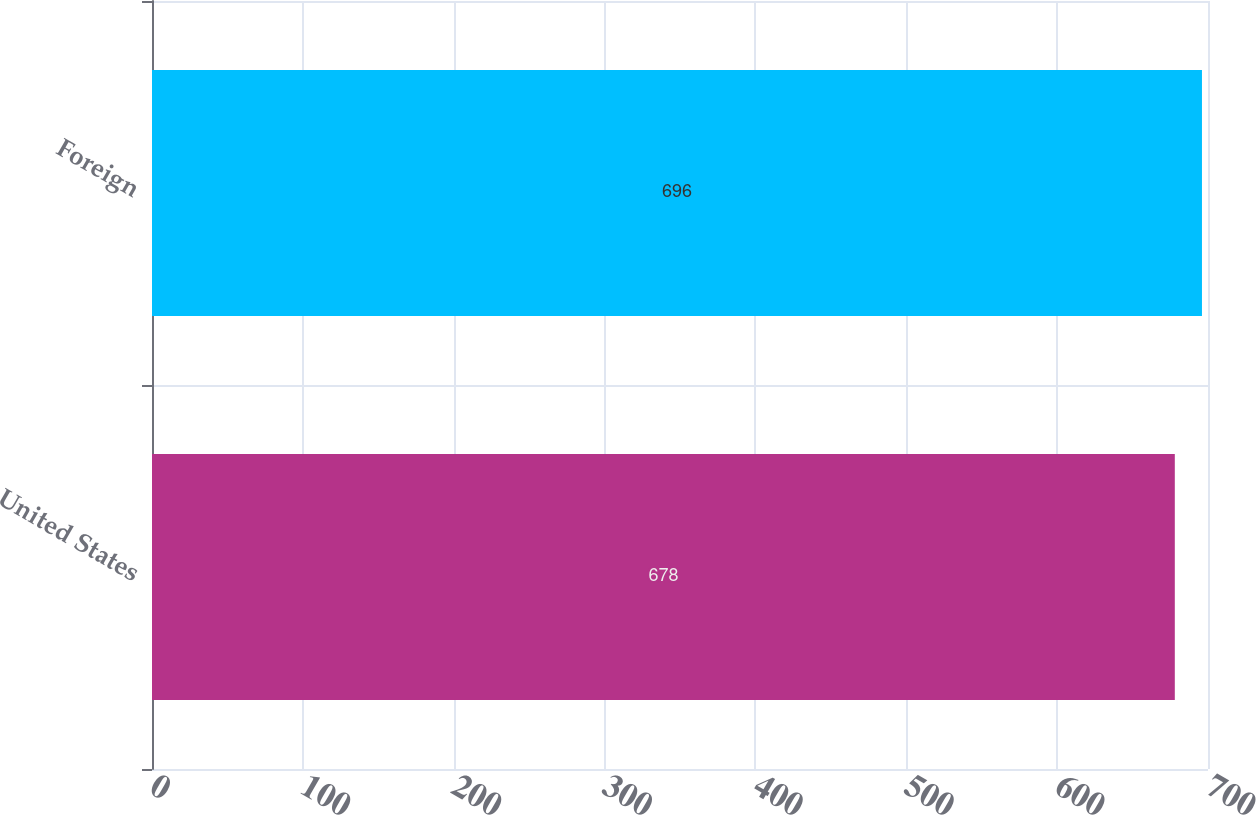Convert chart to OTSL. <chart><loc_0><loc_0><loc_500><loc_500><bar_chart><fcel>United States<fcel>Foreign<nl><fcel>678<fcel>696<nl></chart> 